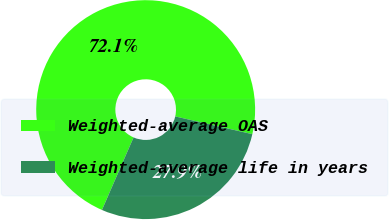Convert chart to OTSL. <chart><loc_0><loc_0><loc_500><loc_500><pie_chart><fcel>Weighted-average OAS<fcel>Weighted-average life in years<nl><fcel>72.06%<fcel>27.94%<nl></chart> 